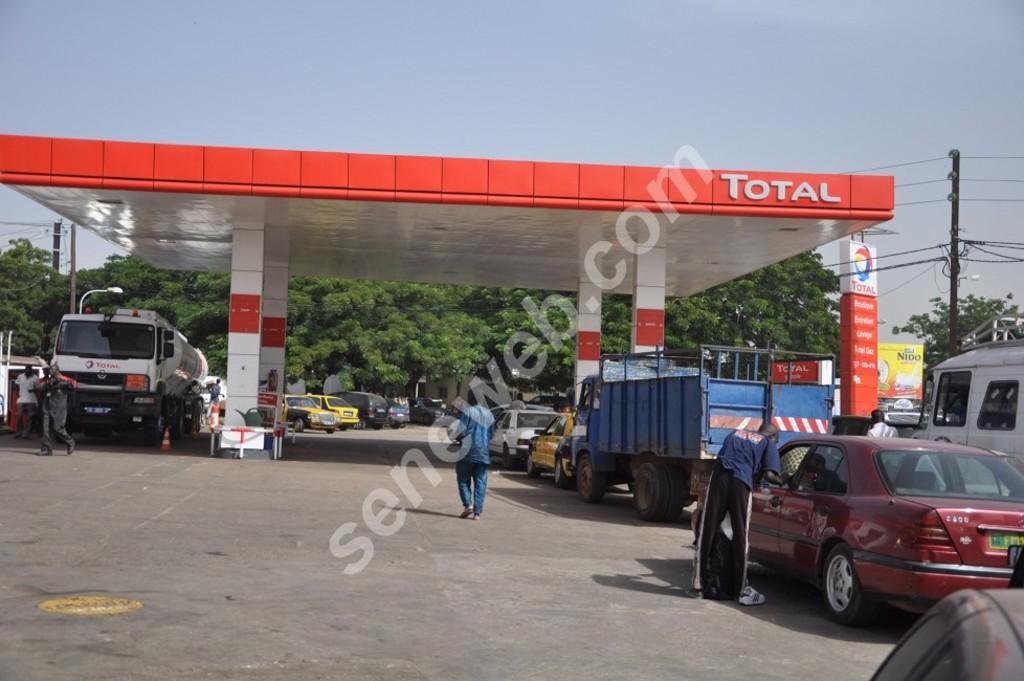Provide a one-sentence caption for the provided image. People are getting gas at a Total gas station. 